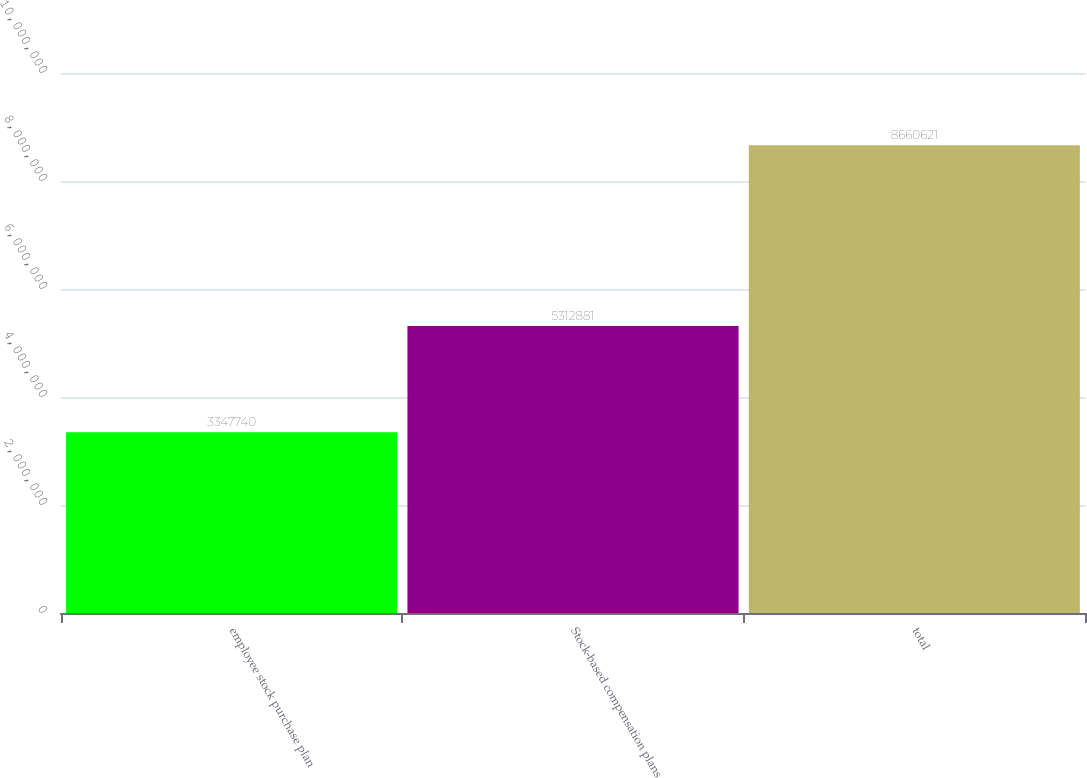<chart> <loc_0><loc_0><loc_500><loc_500><bar_chart><fcel>employee stock purchase plan<fcel>Stock-based compensation plans<fcel>total<nl><fcel>3.34774e+06<fcel>5.31288e+06<fcel>8.66062e+06<nl></chart> 